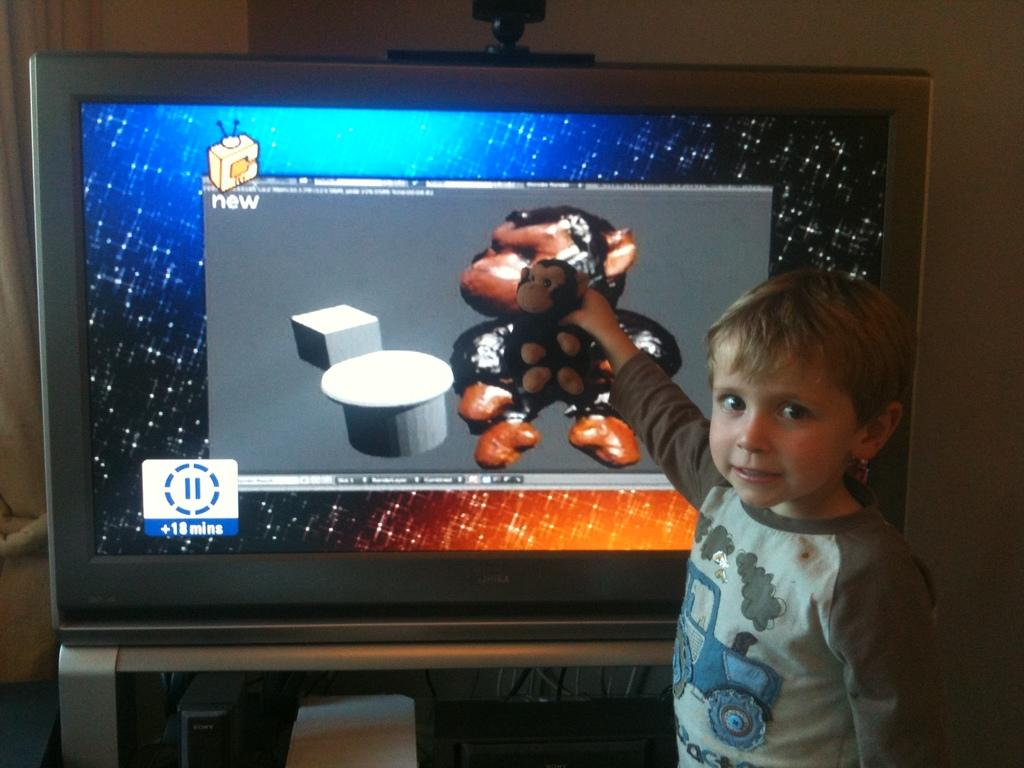What is the boy in the image holding? The boy is holding a soft toy. What is the main object in the image besides the boy? There is a television in the image. How is the television positioned in the image? The television is placed on a stand. What can be seen in the background of the image? There is a wall in the background of the image. What type of locket is the boy wearing in the image? There is no locket visible on the boy in the image. Is the boy using a whip to play with the soft toy in the image? A: There is no whip present in the image, and the boy is not using any such object to play with the soft toy. 